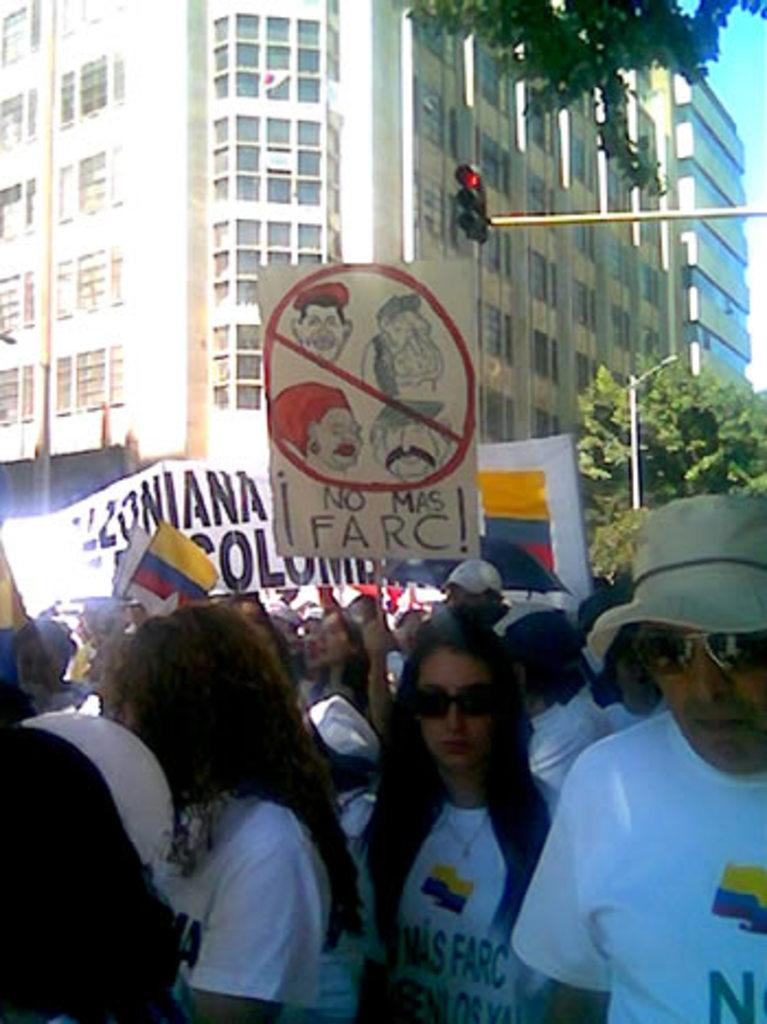What type of structures are visible in the image? The image contains buildings with windows. What is happening at the bottom of the image? There is a large crowd at the bottom of the image. What can be seen being held by the people in the crowd? Placards and banners are present in the image. What is located on the right side of the image? There are trees and signal lights on the right side of the image. How many tomatoes are being thrown in the image? There are no tomatoes present in the image. What type of bikes can be seen in the image? There are no bikes present in the image. 